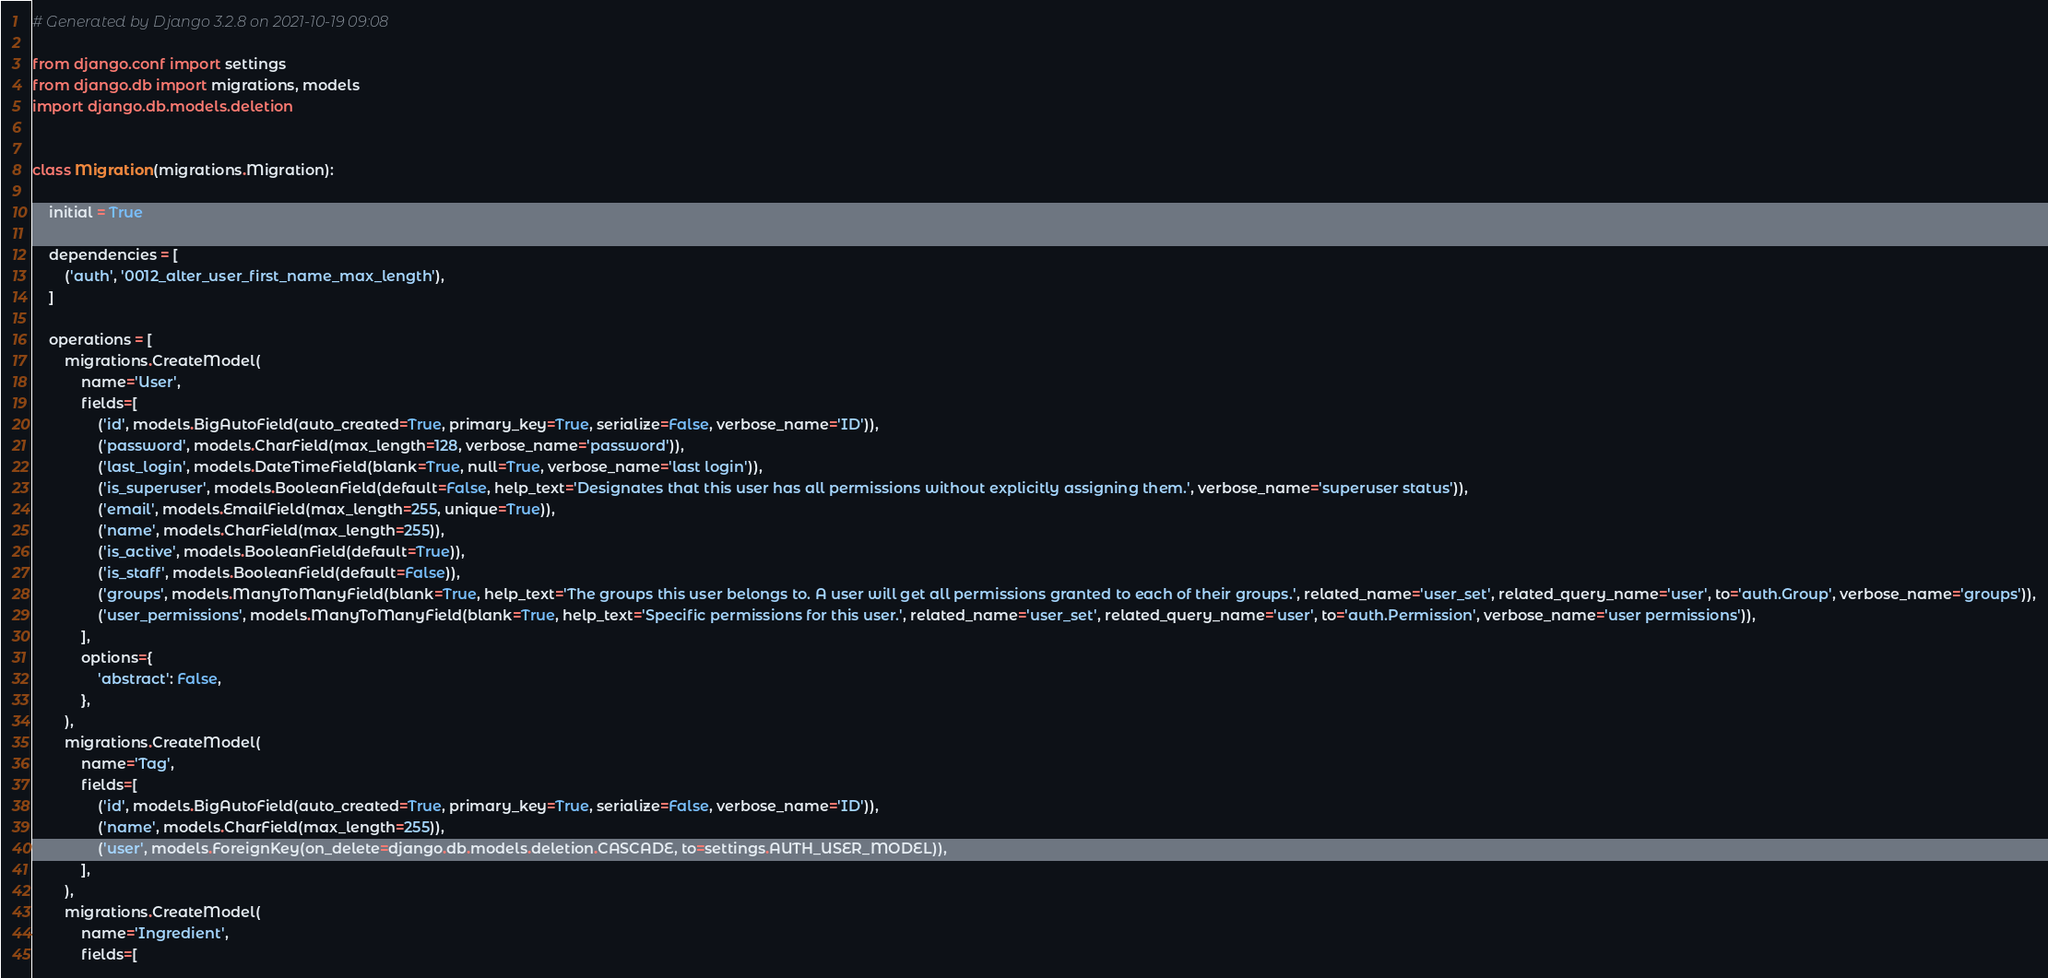<code> <loc_0><loc_0><loc_500><loc_500><_Python_># Generated by Django 3.2.8 on 2021-10-19 09:08

from django.conf import settings
from django.db import migrations, models
import django.db.models.deletion


class Migration(migrations.Migration):

    initial = True

    dependencies = [
        ('auth', '0012_alter_user_first_name_max_length'),
    ]

    operations = [
        migrations.CreateModel(
            name='User',
            fields=[
                ('id', models.BigAutoField(auto_created=True, primary_key=True, serialize=False, verbose_name='ID')),
                ('password', models.CharField(max_length=128, verbose_name='password')),
                ('last_login', models.DateTimeField(blank=True, null=True, verbose_name='last login')),
                ('is_superuser', models.BooleanField(default=False, help_text='Designates that this user has all permissions without explicitly assigning them.', verbose_name='superuser status')),
                ('email', models.EmailField(max_length=255, unique=True)),
                ('name', models.CharField(max_length=255)),
                ('is_active', models.BooleanField(default=True)),
                ('is_staff', models.BooleanField(default=False)),
                ('groups', models.ManyToManyField(blank=True, help_text='The groups this user belongs to. A user will get all permissions granted to each of their groups.', related_name='user_set', related_query_name='user', to='auth.Group', verbose_name='groups')),
                ('user_permissions', models.ManyToManyField(blank=True, help_text='Specific permissions for this user.', related_name='user_set', related_query_name='user', to='auth.Permission', verbose_name='user permissions')),
            ],
            options={
                'abstract': False,
            },
        ),
        migrations.CreateModel(
            name='Tag',
            fields=[
                ('id', models.BigAutoField(auto_created=True, primary_key=True, serialize=False, verbose_name='ID')),
                ('name', models.CharField(max_length=255)),
                ('user', models.ForeignKey(on_delete=django.db.models.deletion.CASCADE, to=settings.AUTH_USER_MODEL)),
            ],
        ),
        migrations.CreateModel(
            name='Ingredient',
            fields=[</code> 